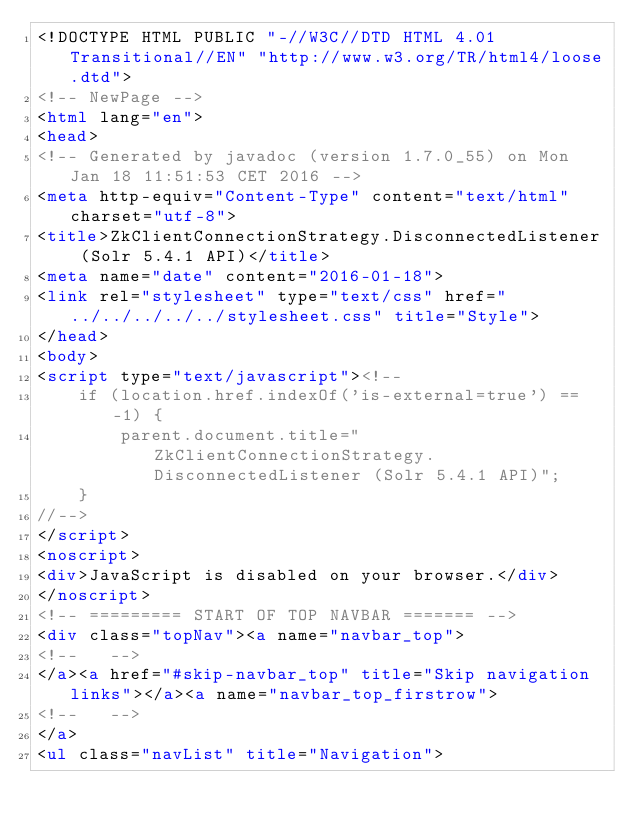Convert code to text. <code><loc_0><loc_0><loc_500><loc_500><_HTML_><!DOCTYPE HTML PUBLIC "-//W3C//DTD HTML 4.01 Transitional//EN" "http://www.w3.org/TR/html4/loose.dtd">
<!-- NewPage -->
<html lang="en">
<head>
<!-- Generated by javadoc (version 1.7.0_55) on Mon Jan 18 11:51:53 CET 2016 -->
<meta http-equiv="Content-Type" content="text/html" charset="utf-8">
<title>ZkClientConnectionStrategy.DisconnectedListener (Solr 5.4.1 API)</title>
<meta name="date" content="2016-01-18">
<link rel="stylesheet" type="text/css" href="../../../../../stylesheet.css" title="Style">
</head>
<body>
<script type="text/javascript"><!--
    if (location.href.indexOf('is-external=true') == -1) {
        parent.document.title="ZkClientConnectionStrategy.DisconnectedListener (Solr 5.4.1 API)";
    }
//-->
</script>
<noscript>
<div>JavaScript is disabled on your browser.</div>
</noscript>
<!-- ========= START OF TOP NAVBAR ======= -->
<div class="topNav"><a name="navbar_top">
<!--   -->
</a><a href="#skip-navbar_top" title="Skip navigation links"></a><a name="navbar_top_firstrow">
<!--   -->
</a>
<ul class="navList" title="Navigation"></code> 